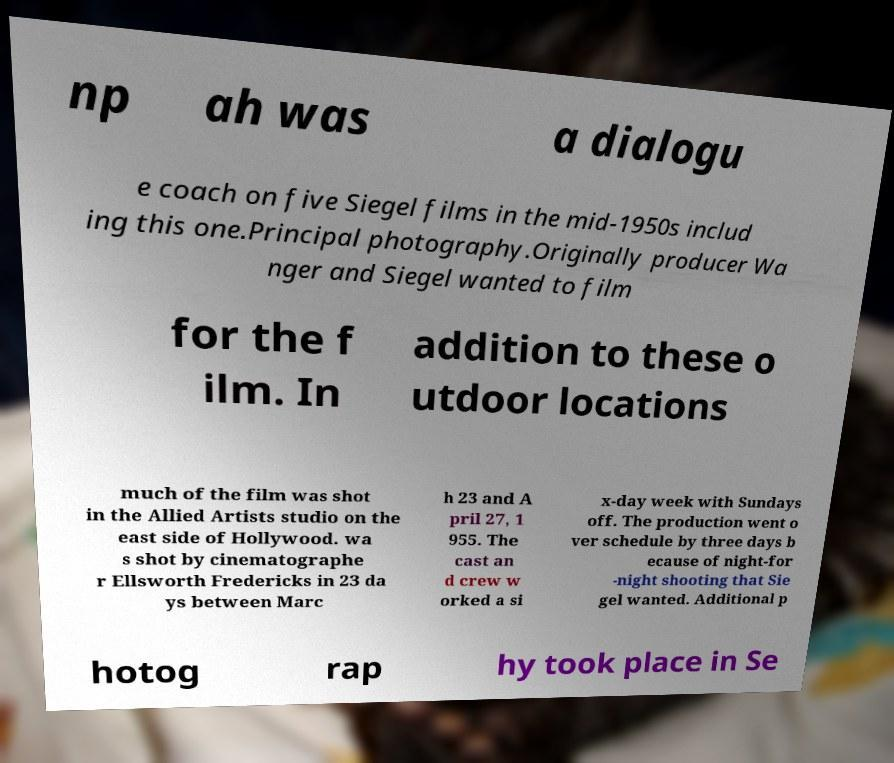I need the written content from this picture converted into text. Can you do that? np ah was a dialogu e coach on five Siegel films in the mid-1950s includ ing this one.Principal photography.Originally producer Wa nger and Siegel wanted to film for the f ilm. In addition to these o utdoor locations much of the film was shot in the Allied Artists studio on the east side of Hollywood. wa s shot by cinematographe r Ellsworth Fredericks in 23 da ys between Marc h 23 and A pril 27, 1 955. The cast an d crew w orked a si x-day week with Sundays off. The production went o ver schedule by three days b ecause of night-for -night shooting that Sie gel wanted. Additional p hotog rap hy took place in Se 